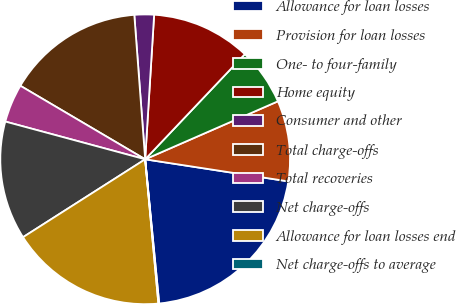<chart> <loc_0><loc_0><loc_500><loc_500><pie_chart><fcel>Allowance for loan losses<fcel>Provision for loan losses<fcel>One- to four-family<fcel>Home equity<fcel>Consumer and other<fcel>Total charge-offs<fcel>Total recoveries<fcel>Net charge-offs<fcel>Allowance for loan losses end<fcel>Net charge-offs to average<nl><fcel>21.02%<fcel>8.99%<fcel>6.37%<fcel>11.09%<fcel>2.18%<fcel>15.33%<fcel>4.28%<fcel>13.23%<fcel>17.42%<fcel>0.09%<nl></chart> 